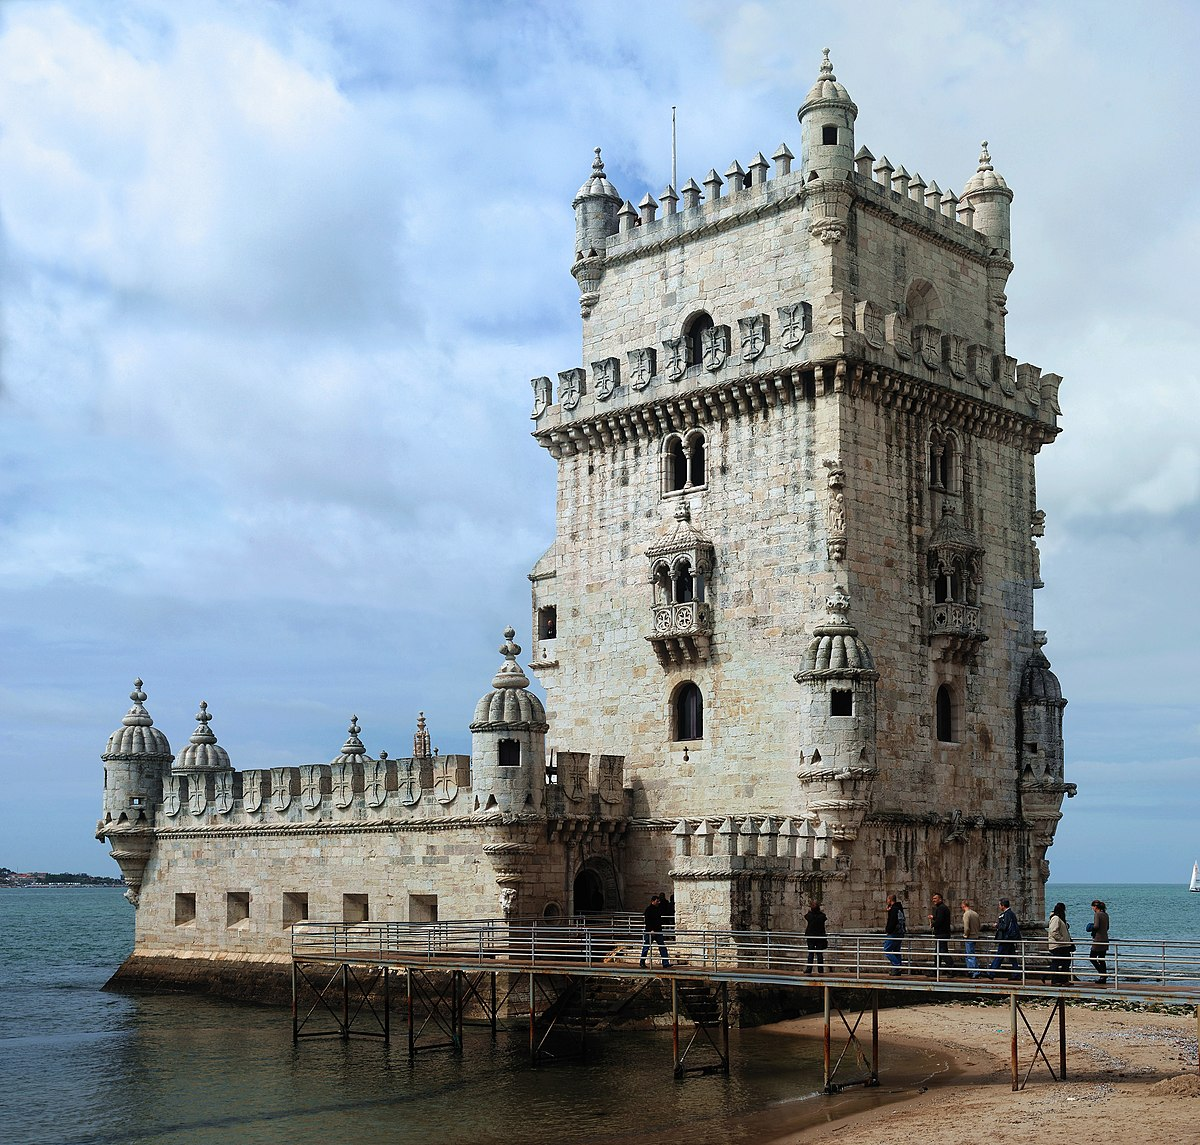How is the Belem Tower used today? Today, the Belem Tower serves predominantly as a museum and a cultural landmark. Visitors can explore its rich history, climb to the upper terraces for panoramic views of the Lisbon coastline, and marvel at the intricate interior rooms that once housed garrisons and prisoners. The site also hosts various cultural events and exhibitions that highlight its historical and architectural significance. It remains a popular attraction for both locals and tourists, symbolizing Lisbon's rich maritime heritage and its role in the Age of Discoveries. 